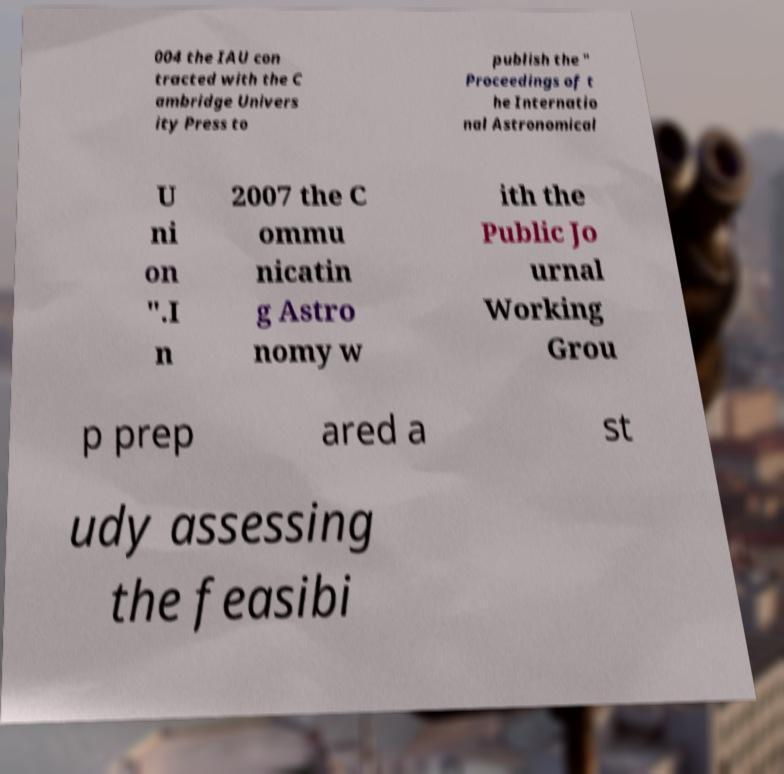I need the written content from this picture converted into text. Can you do that? 004 the IAU con tracted with the C ambridge Univers ity Press to publish the " Proceedings of t he Internatio nal Astronomical U ni on ".I n 2007 the C ommu nicatin g Astro nomy w ith the Public Jo urnal Working Grou p prep ared a st udy assessing the feasibi 